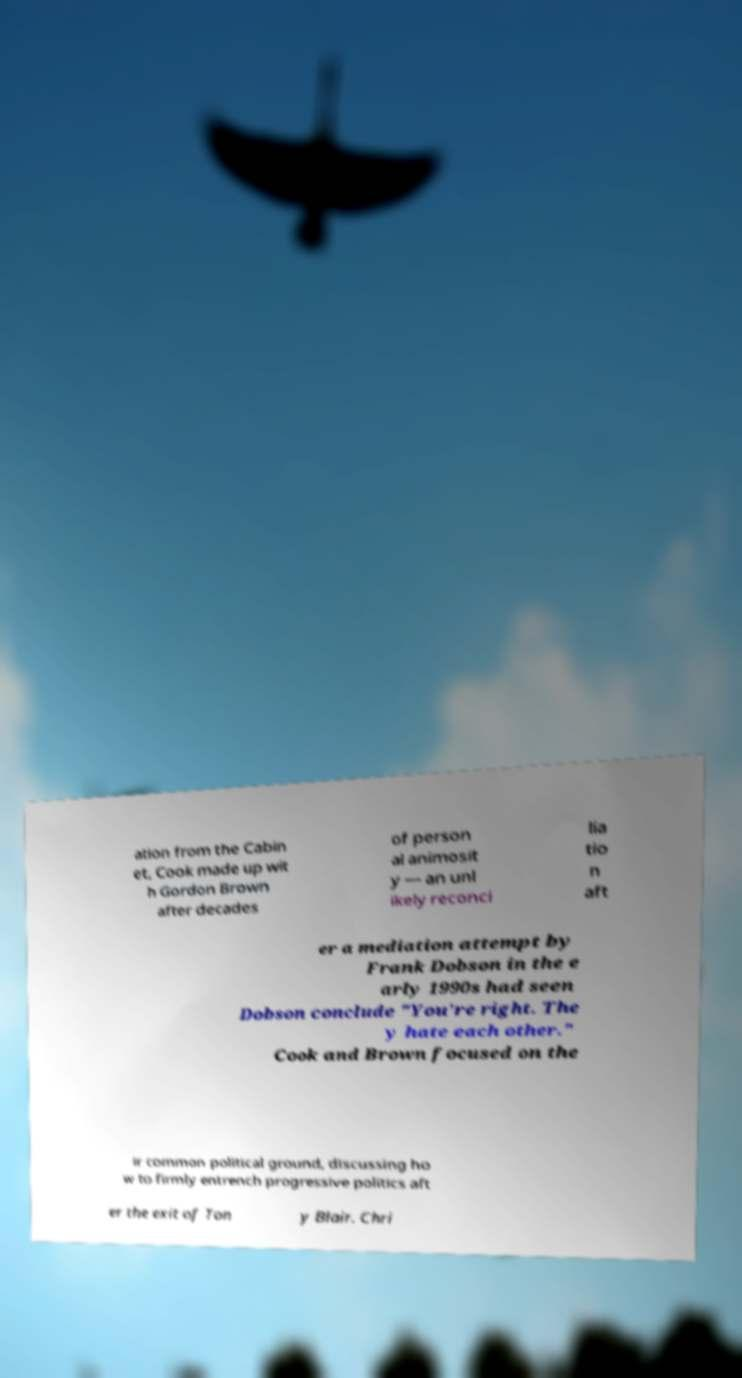For documentation purposes, I need the text within this image transcribed. Could you provide that? ation from the Cabin et, Cook made up wit h Gordon Brown after decades of person al animosit y — an unl ikely reconci lia tio n aft er a mediation attempt by Frank Dobson in the e arly 1990s had seen Dobson conclude "You're right. The y hate each other." Cook and Brown focused on the ir common political ground, discussing ho w to firmly entrench progressive politics aft er the exit of Ton y Blair. Chri 